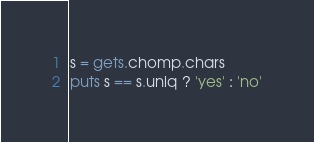Convert code to text. <code><loc_0><loc_0><loc_500><loc_500><_Ruby_>s = gets.chomp.chars
puts s == s.uniq ? 'yes' : 'no'
</code> 